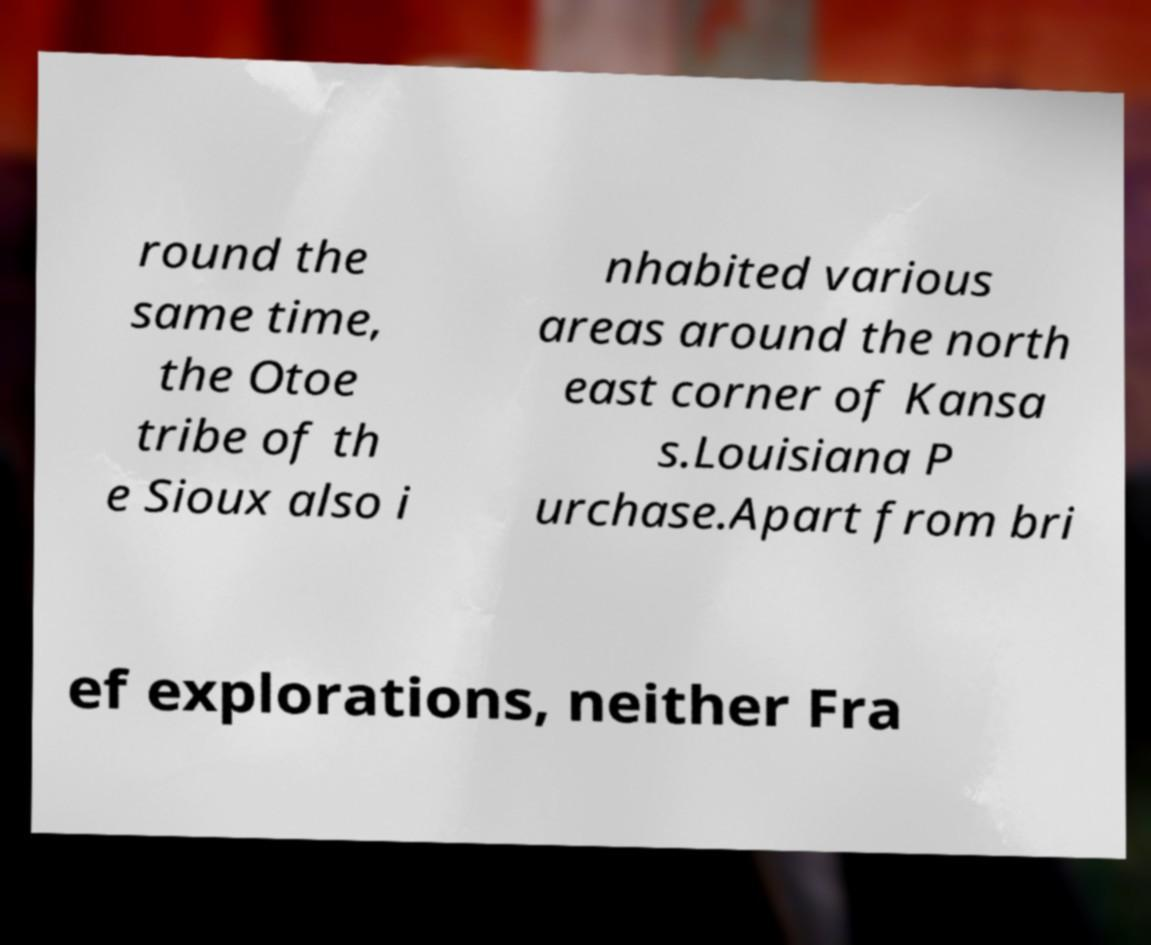Can you read and provide the text displayed in the image?This photo seems to have some interesting text. Can you extract and type it out for me? round the same time, the Otoe tribe of th e Sioux also i nhabited various areas around the north east corner of Kansa s.Louisiana P urchase.Apart from bri ef explorations, neither Fra 